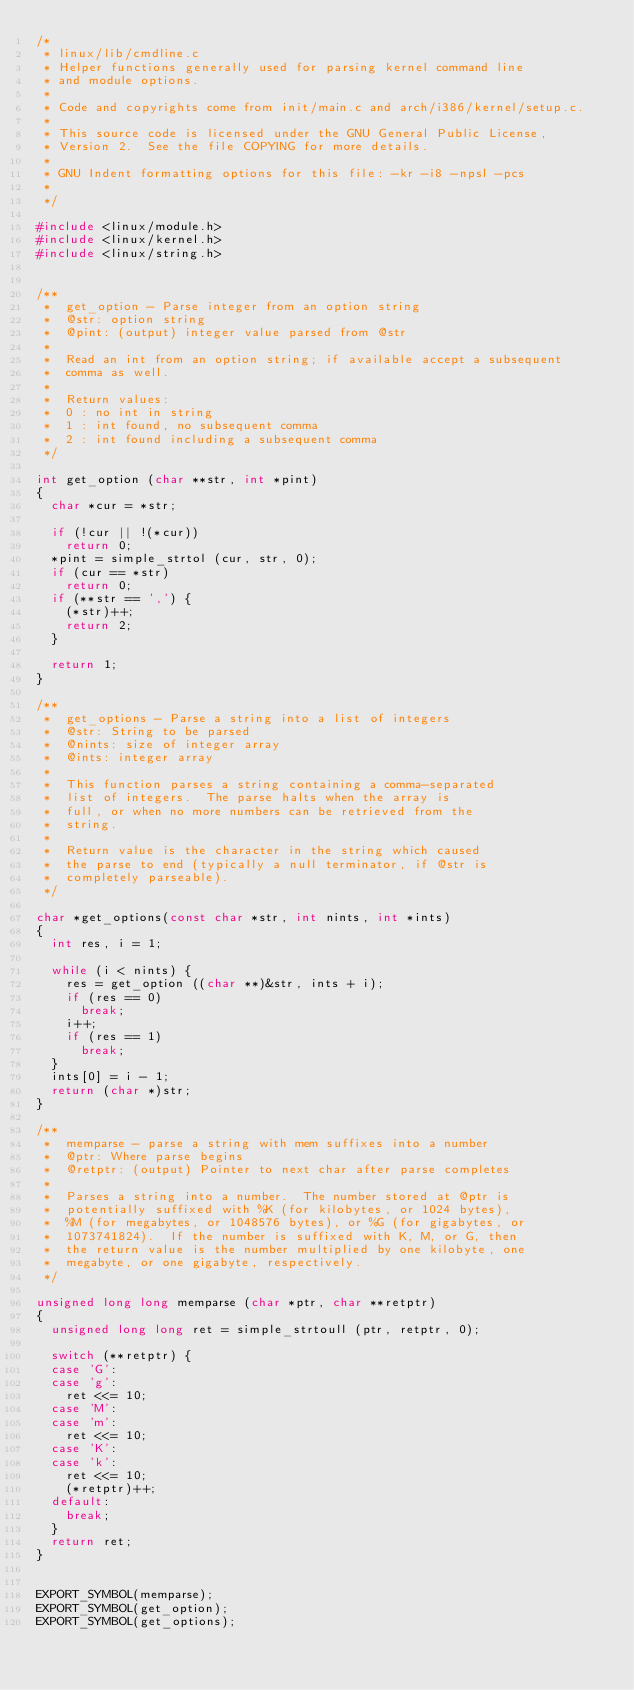Convert code to text. <code><loc_0><loc_0><loc_500><loc_500><_C_>/*
 * linux/lib/cmdline.c
 * Helper functions generally used for parsing kernel command line
 * and module options.
 *
 * Code and copyrights come from init/main.c and arch/i386/kernel/setup.c.
 *
 * This source code is licensed under the GNU General Public License,
 * Version 2.  See the file COPYING for more details.
 *
 * GNU Indent formatting options for this file: -kr -i8 -npsl -pcs
 *
 */

#include <linux/module.h>
#include <linux/kernel.h>
#include <linux/string.h>


/**
 *	get_option - Parse integer from an option string
 *	@str: option string
 *	@pint: (output) integer value parsed from @str
 *
 *	Read an int from an option string; if available accept a subsequent
 *	comma as well.
 *
 *	Return values:
 *	0 : no int in string
 *	1 : int found, no subsequent comma
 *	2 : int found including a subsequent comma
 */

int get_option (char **str, int *pint)
{
	char *cur = *str;

	if (!cur || !(*cur))
		return 0;
	*pint = simple_strtol (cur, str, 0);
	if (cur == *str)
		return 0;
	if (**str == ',') {
		(*str)++;
		return 2;
	}

	return 1;
}

/**
 *	get_options - Parse a string into a list of integers
 *	@str: String to be parsed
 *	@nints: size of integer array
 *	@ints: integer array
 *
 *	This function parses a string containing a comma-separated
 *	list of integers.  The parse halts when the array is
 *	full, or when no more numbers can be retrieved from the
 *	string.
 *
 *	Return value is the character in the string which caused
 *	the parse to end (typically a null terminator, if @str is
 *	completely parseable).
 */
 
char *get_options(const char *str, int nints, int *ints)
{
	int res, i = 1;

	while (i < nints) {
		res = get_option ((char **)&str, ints + i);
		if (res == 0)
			break;
		i++;
		if (res == 1)
			break;
	}
	ints[0] = i - 1;
	return (char *)str;
}

/**
 *	memparse - parse a string with mem suffixes into a number
 *	@ptr: Where parse begins
 *	@retptr: (output) Pointer to next char after parse completes
 *
 *	Parses a string into a number.  The number stored at @ptr is
 *	potentially suffixed with %K (for kilobytes, or 1024 bytes),
 *	%M (for megabytes, or 1048576 bytes), or %G (for gigabytes, or
 *	1073741824).  If the number is suffixed with K, M, or G, then
 *	the return value is the number multiplied by one kilobyte, one
 *	megabyte, or one gigabyte, respectively.
 */

unsigned long long memparse (char *ptr, char **retptr)
{
	unsigned long long ret = simple_strtoull (ptr, retptr, 0);

	switch (**retptr) {
	case 'G':
	case 'g':
		ret <<= 10;
	case 'M':
	case 'm':
		ret <<= 10;
	case 'K':
	case 'k':
		ret <<= 10;
		(*retptr)++;
	default:
		break;
	}
	return ret;
}


EXPORT_SYMBOL(memparse);
EXPORT_SYMBOL(get_option);
EXPORT_SYMBOL(get_options);
</code> 